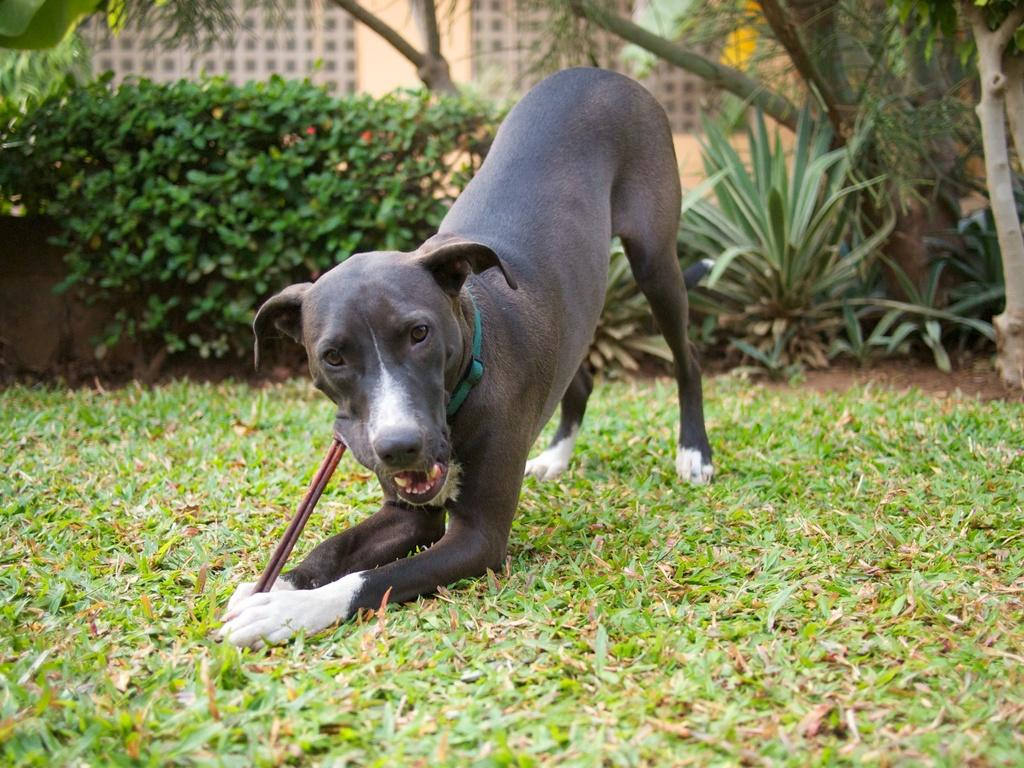What is the main subject in the center of the image? There is a dog in the center of the image. What can be seen in the background of the image? There are trees, plants, and buildings in the background of the image. What type of surface is visible at the bottom of the image? There is ground visible at the bottom of the image. What disease is the dog suffering from in the image? There is no indication in the image that the dog is suffering from any disease. 